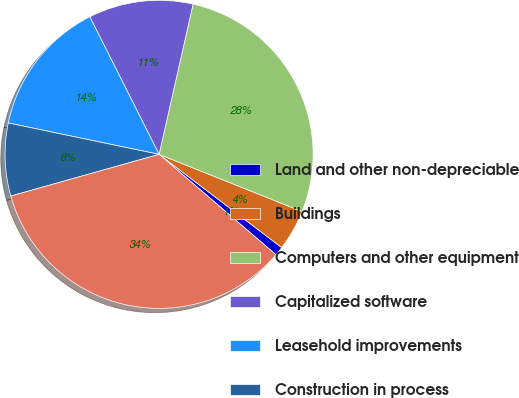Convert chart. <chart><loc_0><loc_0><loc_500><loc_500><pie_chart><fcel>Land and other non-depreciable<fcel>Buildings<fcel>Computers and other equipment<fcel>Capitalized software<fcel>Leasehold improvements<fcel>Construction in process<fcel>Less Accumulated depreciation<nl><fcel>0.95%<fcel>4.29%<fcel>27.52%<fcel>10.97%<fcel>14.31%<fcel>7.63%<fcel>34.35%<nl></chart> 